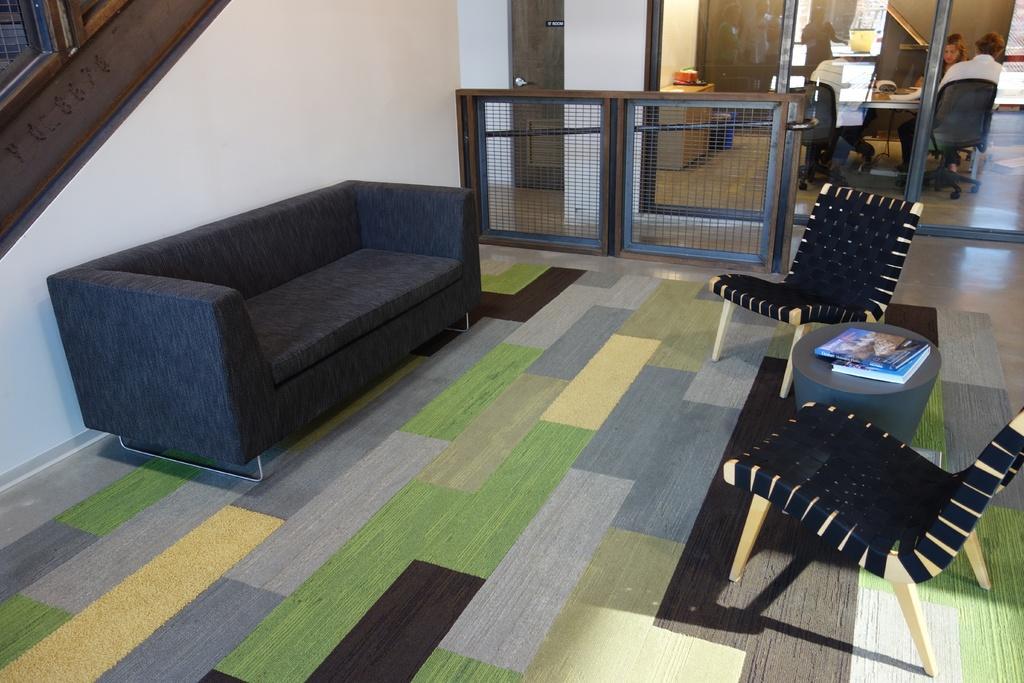Can you describe this image briefly? This image consists of a room in which there is a sofa, chairs, a stool and in the top right corner there there is a table and chairs around the table and people are sitting in chairs. 